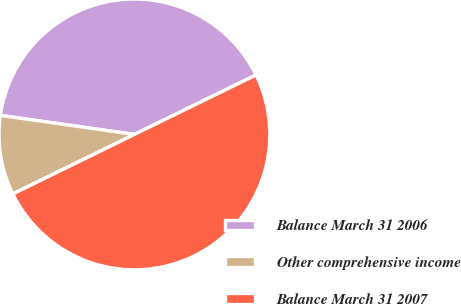Convert chart to OTSL. <chart><loc_0><loc_0><loc_500><loc_500><pie_chart><fcel>Balance March 31 2006<fcel>Other comprehensive income<fcel>Balance March 31 2007<nl><fcel>40.51%<fcel>9.49%<fcel>50.0%<nl></chart> 